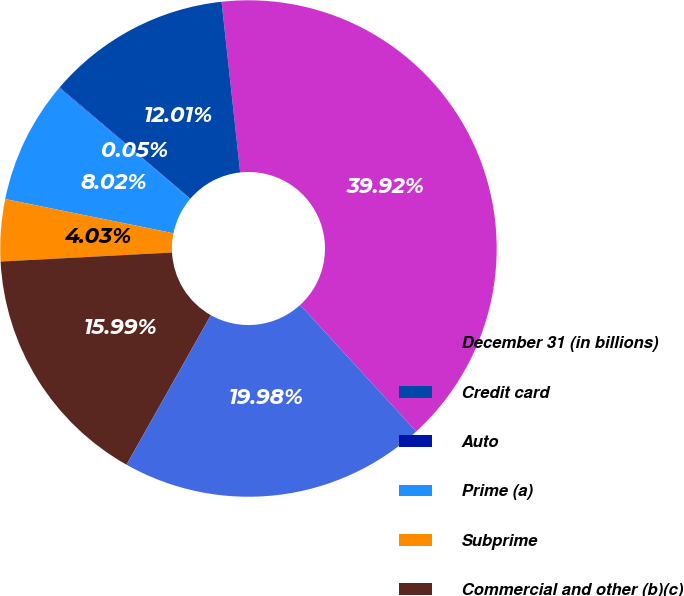Convert chart. <chart><loc_0><loc_0><loc_500><loc_500><pie_chart><fcel>December 31 (in billions)<fcel>Credit card<fcel>Auto<fcel>Prime (a)<fcel>Subprime<fcel>Commercial and other (b)(c)<fcel>Total<nl><fcel>39.92%<fcel>12.01%<fcel>0.05%<fcel>8.02%<fcel>4.03%<fcel>15.99%<fcel>19.98%<nl></chart> 